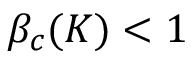Convert formula to latex. <formula><loc_0><loc_0><loc_500><loc_500>\beta _ { c } ( K ) < 1</formula> 